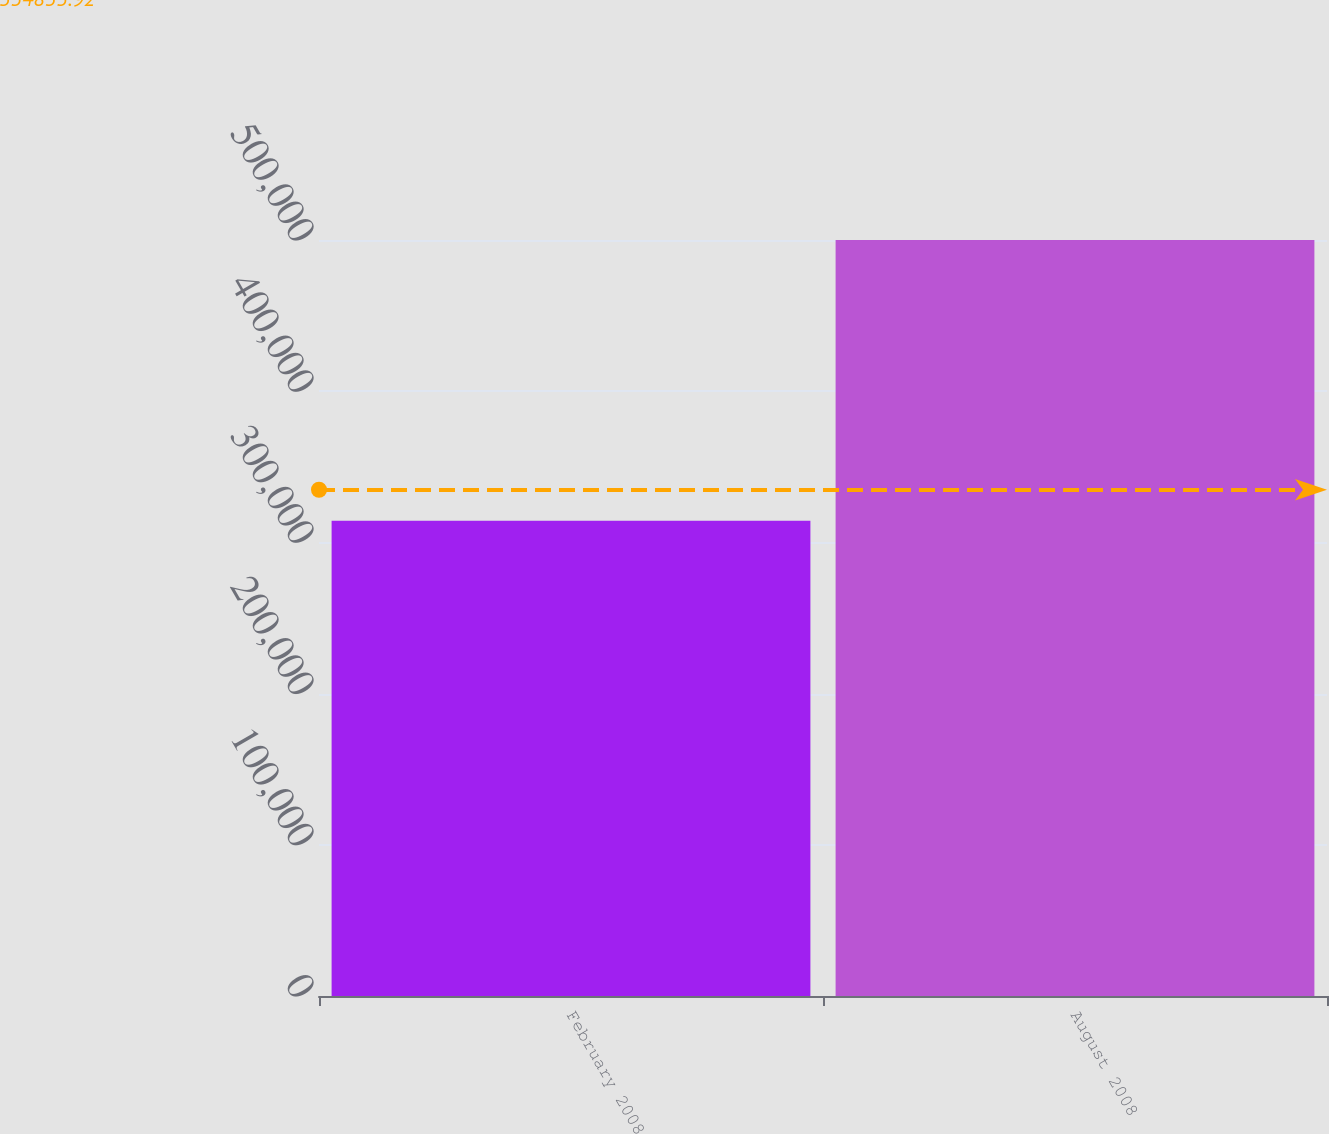<chart> <loc_0><loc_0><loc_500><loc_500><bar_chart><fcel>February 2008<fcel>August 2008<nl><fcel>314389<fcel>500000<nl></chart> 